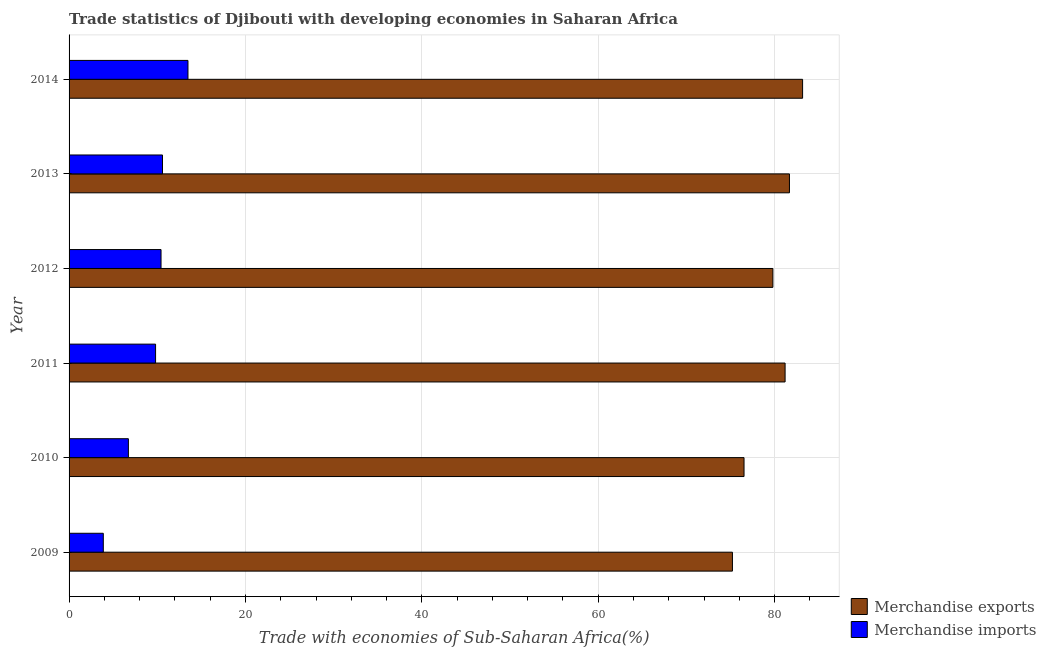How many different coloured bars are there?
Your answer should be very brief. 2. How many groups of bars are there?
Give a very brief answer. 6. What is the label of the 2nd group of bars from the top?
Give a very brief answer. 2013. In how many cases, is the number of bars for a given year not equal to the number of legend labels?
Your answer should be very brief. 0. What is the merchandise imports in 2013?
Offer a very short reply. 10.59. Across all years, what is the maximum merchandise imports?
Your response must be concise. 13.48. Across all years, what is the minimum merchandise imports?
Give a very brief answer. 3.88. In which year was the merchandise imports maximum?
Ensure brevity in your answer.  2014. In which year was the merchandise imports minimum?
Provide a succinct answer. 2009. What is the total merchandise exports in the graph?
Give a very brief answer. 477.62. What is the difference between the merchandise exports in 2012 and that in 2014?
Keep it short and to the point. -3.37. What is the difference between the merchandise imports in 2009 and the merchandise exports in 2012?
Offer a terse response. -75.93. What is the average merchandise imports per year?
Ensure brevity in your answer.  9.15. In the year 2012, what is the difference between the merchandise exports and merchandise imports?
Your answer should be compact. 69.38. In how many years, is the merchandise imports greater than 76 %?
Make the answer very short. 0. What is the ratio of the merchandise exports in 2011 to that in 2014?
Offer a terse response. 0.98. What is the difference between the highest and the second highest merchandise imports?
Provide a succinct answer. 2.89. Is the sum of the merchandise imports in 2011 and 2012 greater than the maximum merchandise exports across all years?
Provide a short and direct response. No. What does the 1st bar from the top in 2010 represents?
Provide a short and direct response. Merchandise imports. What does the 2nd bar from the bottom in 2009 represents?
Provide a short and direct response. Merchandise imports. Are all the bars in the graph horizontal?
Your answer should be very brief. Yes. What is the difference between two consecutive major ticks on the X-axis?
Your answer should be very brief. 20. Does the graph contain any zero values?
Your response must be concise. No. Does the graph contain grids?
Provide a short and direct response. Yes. What is the title of the graph?
Your answer should be compact. Trade statistics of Djibouti with developing economies in Saharan Africa. What is the label or title of the X-axis?
Your answer should be compact. Trade with economies of Sub-Saharan Africa(%). What is the Trade with economies of Sub-Saharan Africa(%) in Merchandise exports in 2009?
Your response must be concise. 75.22. What is the Trade with economies of Sub-Saharan Africa(%) in Merchandise imports in 2009?
Give a very brief answer. 3.88. What is the Trade with economies of Sub-Saharan Africa(%) of Merchandise exports in 2010?
Offer a very short reply. 76.54. What is the Trade with economies of Sub-Saharan Africa(%) of Merchandise imports in 2010?
Provide a short and direct response. 6.73. What is the Trade with economies of Sub-Saharan Africa(%) of Merchandise exports in 2011?
Keep it short and to the point. 81.19. What is the Trade with economies of Sub-Saharan Africa(%) of Merchandise imports in 2011?
Make the answer very short. 9.81. What is the Trade with economies of Sub-Saharan Africa(%) in Merchandise exports in 2012?
Offer a very short reply. 79.81. What is the Trade with economies of Sub-Saharan Africa(%) of Merchandise imports in 2012?
Offer a very short reply. 10.43. What is the Trade with economies of Sub-Saharan Africa(%) in Merchandise exports in 2013?
Keep it short and to the point. 81.69. What is the Trade with economies of Sub-Saharan Africa(%) of Merchandise imports in 2013?
Make the answer very short. 10.59. What is the Trade with economies of Sub-Saharan Africa(%) in Merchandise exports in 2014?
Provide a succinct answer. 83.18. What is the Trade with economies of Sub-Saharan Africa(%) in Merchandise imports in 2014?
Provide a short and direct response. 13.48. Across all years, what is the maximum Trade with economies of Sub-Saharan Africa(%) in Merchandise exports?
Give a very brief answer. 83.18. Across all years, what is the maximum Trade with economies of Sub-Saharan Africa(%) of Merchandise imports?
Keep it short and to the point. 13.48. Across all years, what is the minimum Trade with economies of Sub-Saharan Africa(%) of Merchandise exports?
Your response must be concise. 75.22. Across all years, what is the minimum Trade with economies of Sub-Saharan Africa(%) in Merchandise imports?
Ensure brevity in your answer.  3.88. What is the total Trade with economies of Sub-Saharan Africa(%) of Merchandise exports in the graph?
Your response must be concise. 477.62. What is the total Trade with economies of Sub-Saharan Africa(%) of Merchandise imports in the graph?
Your answer should be very brief. 54.92. What is the difference between the Trade with economies of Sub-Saharan Africa(%) of Merchandise exports in 2009 and that in 2010?
Offer a very short reply. -1.32. What is the difference between the Trade with economies of Sub-Saharan Africa(%) in Merchandise imports in 2009 and that in 2010?
Give a very brief answer. -2.84. What is the difference between the Trade with economies of Sub-Saharan Africa(%) in Merchandise exports in 2009 and that in 2011?
Keep it short and to the point. -5.97. What is the difference between the Trade with economies of Sub-Saharan Africa(%) in Merchandise imports in 2009 and that in 2011?
Your answer should be very brief. -5.93. What is the difference between the Trade with economies of Sub-Saharan Africa(%) of Merchandise exports in 2009 and that in 2012?
Provide a short and direct response. -4.59. What is the difference between the Trade with economies of Sub-Saharan Africa(%) of Merchandise imports in 2009 and that in 2012?
Make the answer very short. -6.55. What is the difference between the Trade with economies of Sub-Saharan Africa(%) of Merchandise exports in 2009 and that in 2013?
Provide a succinct answer. -6.47. What is the difference between the Trade with economies of Sub-Saharan Africa(%) in Merchandise imports in 2009 and that in 2013?
Your answer should be compact. -6.71. What is the difference between the Trade with economies of Sub-Saharan Africa(%) in Merchandise exports in 2009 and that in 2014?
Offer a very short reply. -7.96. What is the difference between the Trade with economies of Sub-Saharan Africa(%) of Merchandise imports in 2009 and that in 2014?
Your answer should be compact. -9.6. What is the difference between the Trade with economies of Sub-Saharan Africa(%) of Merchandise exports in 2010 and that in 2011?
Ensure brevity in your answer.  -4.66. What is the difference between the Trade with economies of Sub-Saharan Africa(%) of Merchandise imports in 2010 and that in 2011?
Your response must be concise. -3.08. What is the difference between the Trade with economies of Sub-Saharan Africa(%) of Merchandise exports in 2010 and that in 2012?
Make the answer very short. -3.27. What is the difference between the Trade with economies of Sub-Saharan Africa(%) of Merchandise imports in 2010 and that in 2012?
Your answer should be very brief. -3.7. What is the difference between the Trade with economies of Sub-Saharan Africa(%) in Merchandise exports in 2010 and that in 2013?
Offer a very short reply. -5.15. What is the difference between the Trade with economies of Sub-Saharan Africa(%) in Merchandise imports in 2010 and that in 2013?
Offer a terse response. -3.87. What is the difference between the Trade with economies of Sub-Saharan Africa(%) of Merchandise exports in 2010 and that in 2014?
Your response must be concise. -6.64. What is the difference between the Trade with economies of Sub-Saharan Africa(%) of Merchandise imports in 2010 and that in 2014?
Offer a terse response. -6.76. What is the difference between the Trade with economies of Sub-Saharan Africa(%) in Merchandise exports in 2011 and that in 2012?
Ensure brevity in your answer.  1.38. What is the difference between the Trade with economies of Sub-Saharan Africa(%) in Merchandise imports in 2011 and that in 2012?
Offer a very short reply. -0.62. What is the difference between the Trade with economies of Sub-Saharan Africa(%) of Merchandise exports in 2011 and that in 2013?
Provide a succinct answer. -0.49. What is the difference between the Trade with economies of Sub-Saharan Africa(%) of Merchandise imports in 2011 and that in 2013?
Make the answer very short. -0.79. What is the difference between the Trade with economies of Sub-Saharan Africa(%) of Merchandise exports in 2011 and that in 2014?
Your answer should be very brief. -1.98. What is the difference between the Trade with economies of Sub-Saharan Africa(%) of Merchandise imports in 2011 and that in 2014?
Provide a short and direct response. -3.67. What is the difference between the Trade with economies of Sub-Saharan Africa(%) in Merchandise exports in 2012 and that in 2013?
Give a very brief answer. -1.88. What is the difference between the Trade with economies of Sub-Saharan Africa(%) in Merchandise imports in 2012 and that in 2013?
Provide a succinct answer. -0.17. What is the difference between the Trade with economies of Sub-Saharan Africa(%) of Merchandise exports in 2012 and that in 2014?
Offer a terse response. -3.37. What is the difference between the Trade with economies of Sub-Saharan Africa(%) in Merchandise imports in 2012 and that in 2014?
Your answer should be compact. -3.05. What is the difference between the Trade with economies of Sub-Saharan Africa(%) of Merchandise exports in 2013 and that in 2014?
Ensure brevity in your answer.  -1.49. What is the difference between the Trade with economies of Sub-Saharan Africa(%) in Merchandise imports in 2013 and that in 2014?
Keep it short and to the point. -2.89. What is the difference between the Trade with economies of Sub-Saharan Africa(%) of Merchandise exports in 2009 and the Trade with economies of Sub-Saharan Africa(%) of Merchandise imports in 2010?
Keep it short and to the point. 68.49. What is the difference between the Trade with economies of Sub-Saharan Africa(%) in Merchandise exports in 2009 and the Trade with economies of Sub-Saharan Africa(%) in Merchandise imports in 2011?
Your answer should be very brief. 65.41. What is the difference between the Trade with economies of Sub-Saharan Africa(%) of Merchandise exports in 2009 and the Trade with economies of Sub-Saharan Africa(%) of Merchandise imports in 2012?
Provide a short and direct response. 64.79. What is the difference between the Trade with economies of Sub-Saharan Africa(%) of Merchandise exports in 2009 and the Trade with economies of Sub-Saharan Africa(%) of Merchandise imports in 2013?
Your answer should be compact. 64.63. What is the difference between the Trade with economies of Sub-Saharan Africa(%) of Merchandise exports in 2009 and the Trade with economies of Sub-Saharan Africa(%) of Merchandise imports in 2014?
Provide a succinct answer. 61.74. What is the difference between the Trade with economies of Sub-Saharan Africa(%) in Merchandise exports in 2010 and the Trade with economies of Sub-Saharan Africa(%) in Merchandise imports in 2011?
Your response must be concise. 66.73. What is the difference between the Trade with economies of Sub-Saharan Africa(%) in Merchandise exports in 2010 and the Trade with economies of Sub-Saharan Africa(%) in Merchandise imports in 2012?
Your answer should be compact. 66.11. What is the difference between the Trade with economies of Sub-Saharan Africa(%) of Merchandise exports in 2010 and the Trade with economies of Sub-Saharan Africa(%) of Merchandise imports in 2013?
Offer a terse response. 65.94. What is the difference between the Trade with economies of Sub-Saharan Africa(%) in Merchandise exports in 2010 and the Trade with economies of Sub-Saharan Africa(%) in Merchandise imports in 2014?
Offer a terse response. 63.05. What is the difference between the Trade with economies of Sub-Saharan Africa(%) in Merchandise exports in 2011 and the Trade with economies of Sub-Saharan Africa(%) in Merchandise imports in 2012?
Give a very brief answer. 70.76. What is the difference between the Trade with economies of Sub-Saharan Africa(%) in Merchandise exports in 2011 and the Trade with economies of Sub-Saharan Africa(%) in Merchandise imports in 2013?
Make the answer very short. 70.6. What is the difference between the Trade with economies of Sub-Saharan Africa(%) in Merchandise exports in 2011 and the Trade with economies of Sub-Saharan Africa(%) in Merchandise imports in 2014?
Your answer should be very brief. 67.71. What is the difference between the Trade with economies of Sub-Saharan Africa(%) in Merchandise exports in 2012 and the Trade with economies of Sub-Saharan Africa(%) in Merchandise imports in 2013?
Offer a very short reply. 69.22. What is the difference between the Trade with economies of Sub-Saharan Africa(%) in Merchandise exports in 2012 and the Trade with economies of Sub-Saharan Africa(%) in Merchandise imports in 2014?
Offer a terse response. 66.33. What is the difference between the Trade with economies of Sub-Saharan Africa(%) in Merchandise exports in 2013 and the Trade with economies of Sub-Saharan Africa(%) in Merchandise imports in 2014?
Give a very brief answer. 68.2. What is the average Trade with economies of Sub-Saharan Africa(%) in Merchandise exports per year?
Give a very brief answer. 79.6. What is the average Trade with economies of Sub-Saharan Africa(%) in Merchandise imports per year?
Your response must be concise. 9.15. In the year 2009, what is the difference between the Trade with economies of Sub-Saharan Africa(%) in Merchandise exports and Trade with economies of Sub-Saharan Africa(%) in Merchandise imports?
Offer a very short reply. 71.34. In the year 2010, what is the difference between the Trade with economies of Sub-Saharan Africa(%) of Merchandise exports and Trade with economies of Sub-Saharan Africa(%) of Merchandise imports?
Your answer should be very brief. 69.81. In the year 2011, what is the difference between the Trade with economies of Sub-Saharan Africa(%) in Merchandise exports and Trade with economies of Sub-Saharan Africa(%) in Merchandise imports?
Your answer should be very brief. 71.38. In the year 2012, what is the difference between the Trade with economies of Sub-Saharan Africa(%) of Merchandise exports and Trade with economies of Sub-Saharan Africa(%) of Merchandise imports?
Keep it short and to the point. 69.38. In the year 2013, what is the difference between the Trade with economies of Sub-Saharan Africa(%) in Merchandise exports and Trade with economies of Sub-Saharan Africa(%) in Merchandise imports?
Your response must be concise. 71.09. In the year 2014, what is the difference between the Trade with economies of Sub-Saharan Africa(%) in Merchandise exports and Trade with economies of Sub-Saharan Africa(%) in Merchandise imports?
Your answer should be compact. 69.69. What is the ratio of the Trade with economies of Sub-Saharan Africa(%) in Merchandise exports in 2009 to that in 2010?
Your answer should be very brief. 0.98. What is the ratio of the Trade with economies of Sub-Saharan Africa(%) of Merchandise imports in 2009 to that in 2010?
Offer a very short reply. 0.58. What is the ratio of the Trade with economies of Sub-Saharan Africa(%) of Merchandise exports in 2009 to that in 2011?
Ensure brevity in your answer.  0.93. What is the ratio of the Trade with economies of Sub-Saharan Africa(%) of Merchandise imports in 2009 to that in 2011?
Make the answer very short. 0.4. What is the ratio of the Trade with economies of Sub-Saharan Africa(%) of Merchandise exports in 2009 to that in 2012?
Keep it short and to the point. 0.94. What is the ratio of the Trade with economies of Sub-Saharan Africa(%) of Merchandise imports in 2009 to that in 2012?
Your answer should be compact. 0.37. What is the ratio of the Trade with economies of Sub-Saharan Africa(%) of Merchandise exports in 2009 to that in 2013?
Provide a short and direct response. 0.92. What is the ratio of the Trade with economies of Sub-Saharan Africa(%) in Merchandise imports in 2009 to that in 2013?
Keep it short and to the point. 0.37. What is the ratio of the Trade with economies of Sub-Saharan Africa(%) in Merchandise exports in 2009 to that in 2014?
Offer a very short reply. 0.9. What is the ratio of the Trade with economies of Sub-Saharan Africa(%) of Merchandise imports in 2009 to that in 2014?
Your answer should be very brief. 0.29. What is the ratio of the Trade with economies of Sub-Saharan Africa(%) of Merchandise exports in 2010 to that in 2011?
Keep it short and to the point. 0.94. What is the ratio of the Trade with economies of Sub-Saharan Africa(%) in Merchandise imports in 2010 to that in 2011?
Offer a terse response. 0.69. What is the ratio of the Trade with economies of Sub-Saharan Africa(%) in Merchandise exports in 2010 to that in 2012?
Keep it short and to the point. 0.96. What is the ratio of the Trade with economies of Sub-Saharan Africa(%) of Merchandise imports in 2010 to that in 2012?
Your response must be concise. 0.64. What is the ratio of the Trade with economies of Sub-Saharan Africa(%) in Merchandise exports in 2010 to that in 2013?
Ensure brevity in your answer.  0.94. What is the ratio of the Trade with economies of Sub-Saharan Africa(%) of Merchandise imports in 2010 to that in 2013?
Offer a terse response. 0.63. What is the ratio of the Trade with economies of Sub-Saharan Africa(%) of Merchandise exports in 2010 to that in 2014?
Your response must be concise. 0.92. What is the ratio of the Trade with economies of Sub-Saharan Africa(%) of Merchandise imports in 2010 to that in 2014?
Give a very brief answer. 0.5. What is the ratio of the Trade with economies of Sub-Saharan Africa(%) of Merchandise exports in 2011 to that in 2012?
Keep it short and to the point. 1.02. What is the ratio of the Trade with economies of Sub-Saharan Africa(%) of Merchandise imports in 2011 to that in 2012?
Provide a short and direct response. 0.94. What is the ratio of the Trade with economies of Sub-Saharan Africa(%) of Merchandise exports in 2011 to that in 2013?
Your answer should be very brief. 0.99. What is the ratio of the Trade with economies of Sub-Saharan Africa(%) in Merchandise imports in 2011 to that in 2013?
Your answer should be compact. 0.93. What is the ratio of the Trade with economies of Sub-Saharan Africa(%) of Merchandise exports in 2011 to that in 2014?
Offer a very short reply. 0.98. What is the ratio of the Trade with economies of Sub-Saharan Africa(%) of Merchandise imports in 2011 to that in 2014?
Offer a terse response. 0.73. What is the ratio of the Trade with economies of Sub-Saharan Africa(%) in Merchandise exports in 2012 to that in 2013?
Offer a terse response. 0.98. What is the ratio of the Trade with economies of Sub-Saharan Africa(%) of Merchandise imports in 2012 to that in 2013?
Keep it short and to the point. 0.98. What is the ratio of the Trade with economies of Sub-Saharan Africa(%) in Merchandise exports in 2012 to that in 2014?
Offer a very short reply. 0.96. What is the ratio of the Trade with economies of Sub-Saharan Africa(%) of Merchandise imports in 2012 to that in 2014?
Your response must be concise. 0.77. What is the ratio of the Trade with economies of Sub-Saharan Africa(%) of Merchandise exports in 2013 to that in 2014?
Offer a very short reply. 0.98. What is the ratio of the Trade with economies of Sub-Saharan Africa(%) of Merchandise imports in 2013 to that in 2014?
Provide a succinct answer. 0.79. What is the difference between the highest and the second highest Trade with economies of Sub-Saharan Africa(%) in Merchandise exports?
Ensure brevity in your answer.  1.49. What is the difference between the highest and the second highest Trade with economies of Sub-Saharan Africa(%) of Merchandise imports?
Your answer should be compact. 2.89. What is the difference between the highest and the lowest Trade with economies of Sub-Saharan Africa(%) of Merchandise exports?
Your answer should be compact. 7.96. What is the difference between the highest and the lowest Trade with economies of Sub-Saharan Africa(%) of Merchandise imports?
Your response must be concise. 9.6. 